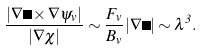Convert formula to latex. <formula><loc_0><loc_0><loc_500><loc_500>\frac { | \nabla \Omega \times \nabla \psi _ { v } | } { | \nabla \chi | } \sim \frac { F _ { v } } { B _ { v } } | \nabla \Omega | \sim \lambda ^ { 3 } .</formula> 